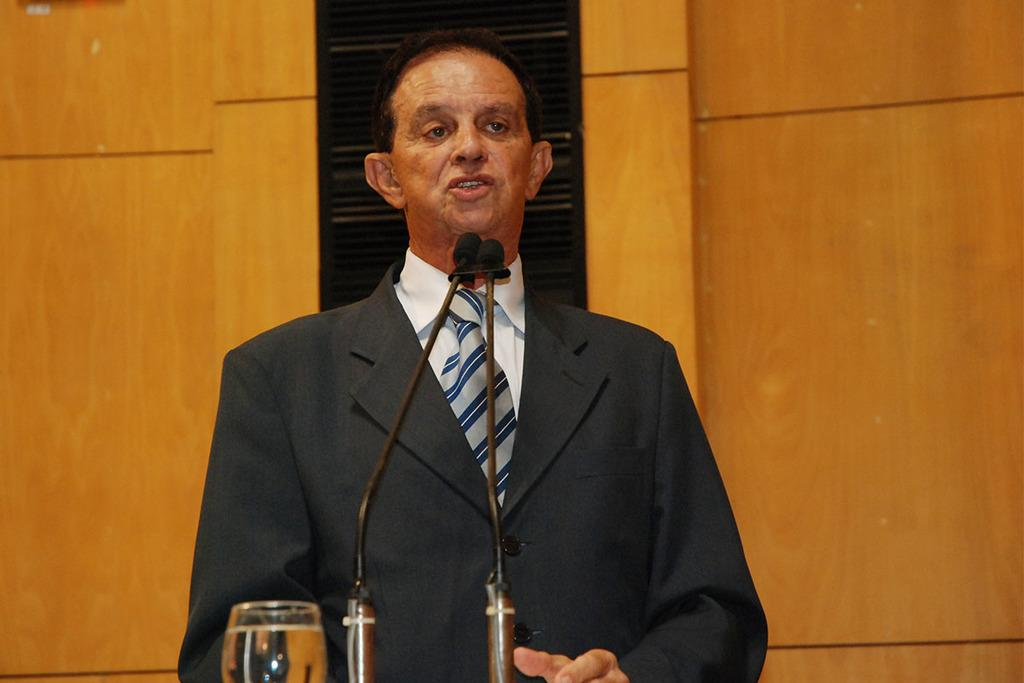Who or what is the main subject in the image? There is a person in the image. What objects are in front of the person? There are two microphones and a glass in front of the person. What is in the glass? The glass is filled with a drink. What can be seen in the background of the image? There is a wall in the background of the image. What type of potato is being used as a flag in the image? There is no potato or flag present in the image. What game is the person playing in the image? There is no game being played in the image; the person is in front of two microphones and a glass with a drink. 